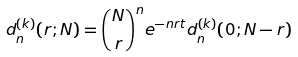Convert formula to latex. <formula><loc_0><loc_0><loc_500><loc_500>d ^ { ( k ) } _ { n } ( r ; N ) = { N \choose r } ^ { n } e ^ { - n r t } d ^ { ( k ) } _ { n } ( 0 ; N - r )</formula> 